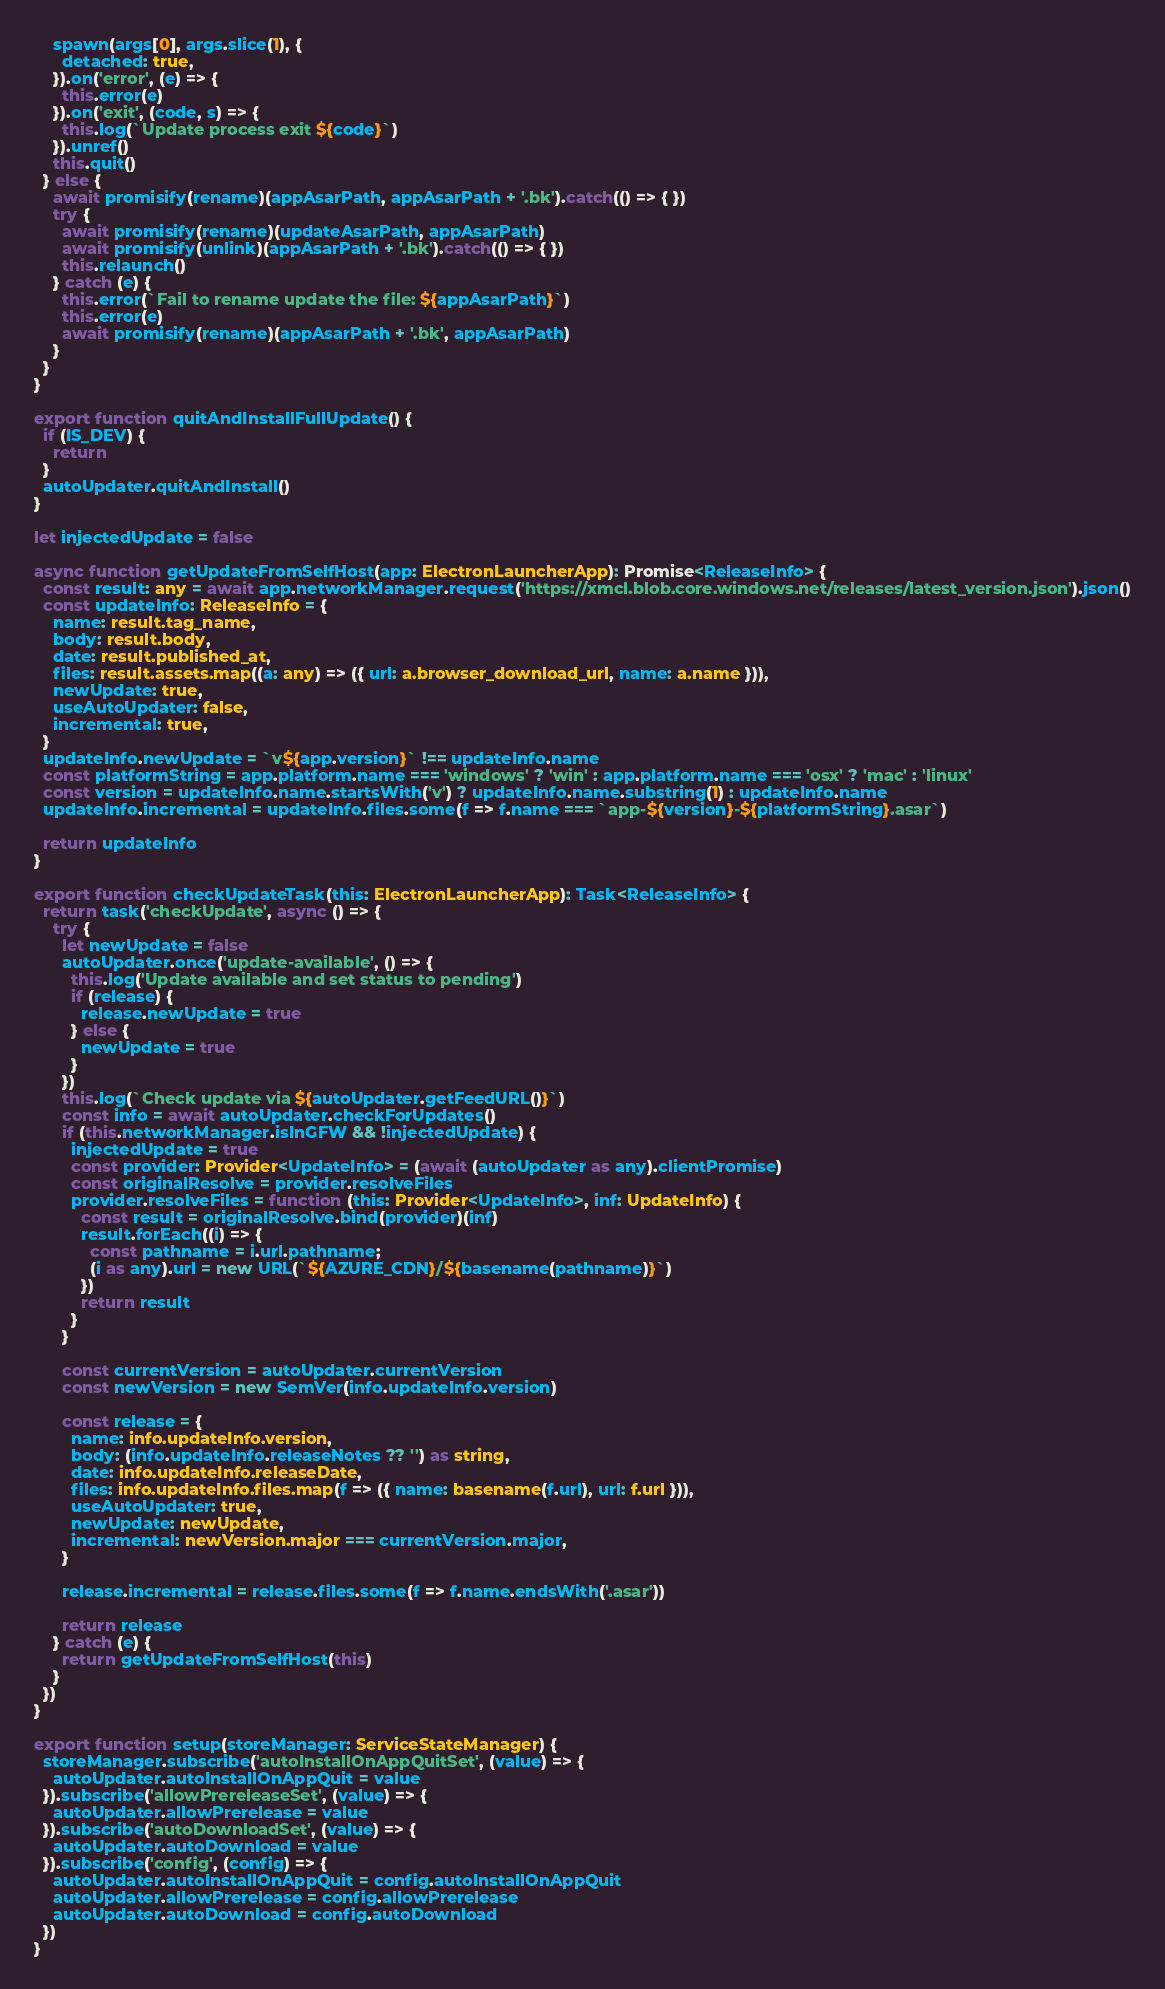<code> <loc_0><loc_0><loc_500><loc_500><_TypeScript_>
    spawn(args[0], args.slice(1), {
      detached: true,
    }).on('error', (e) => {
      this.error(e)
    }).on('exit', (code, s) => {
      this.log(`Update process exit ${code}`)
    }).unref()
    this.quit()
  } else {
    await promisify(rename)(appAsarPath, appAsarPath + '.bk').catch(() => { })
    try {
      await promisify(rename)(updateAsarPath, appAsarPath)
      await promisify(unlink)(appAsarPath + '.bk').catch(() => { })
      this.relaunch()
    } catch (e) {
      this.error(`Fail to rename update the file: ${appAsarPath}`)
      this.error(e)
      await promisify(rename)(appAsarPath + '.bk', appAsarPath)
    }
  }
}

export function quitAndInstallFullUpdate() {
  if (IS_DEV) {
    return
  }
  autoUpdater.quitAndInstall()
}

let injectedUpdate = false

async function getUpdateFromSelfHost(app: ElectronLauncherApp): Promise<ReleaseInfo> {
  const result: any = await app.networkManager.request('https://xmcl.blob.core.windows.net/releases/latest_version.json').json()
  const updateInfo: ReleaseInfo = {
    name: result.tag_name,
    body: result.body,
    date: result.published_at,
    files: result.assets.map((a: any) => ({ url: a.browser_download_url, name: a.name })),
    newUpdate: true,
    useAutoUpdater: false,
    incremental: true,
  }
  updateInfo.newUpdate = `v${app.version}` !== updateInfo.name
  const platformString = app.platform.name === 'windows' ? 'win' : app.platform.name === 'osx' ? 'mac' : 'linux'
  const version = updateInfo.name.startsWith('v') ? updateInfo.name.substring(1) : updateInfo.name
  updateInfo.incremental = updateInfo.files.some(f => f.name === `app-${version}-${platformString}.asar`)

  return updateInfo
}

export function checkUpdateTask(this: ElectronLauncherApp): Task<ReleaseInfo> {
  return task('checkUpdate', async () => {
    try {
      let newUpdate = false
      autoUpdater.once('update-available', () => {
        this.log('Update available and set status to pending')
        if (release) {
          release.newUpdate = true
        } else {
          newUpdate = true
        }
      })
      this.log(`Check update via ${autoUpdater.getFeedURL()}`)
      const info = await autoUpdater.checkForUpdates()
      if (this.networkManager.isInGFW && !injectedUpdate) {
        injectedUpdate = true
        const provider: Provider<UpdateInfo> = (await (autoUpdater as any).clientPromise)
        const originalResolve = provider.resolveFiles
        provider.resolveFiles = function (this: Provider<UpdateInfo>, inf: UpdateInfo) {
          const result = originalResolve.bind(provider)(inf)
          result.forEach((i) => {
            const pathname = i.url.pathname;
            (i as any).url = new URL(`${AZURE_CDN}/${basename(pathname)}`)
          })
          return result
        }
      }

      const currentVersion = autoUpdater.currentVersion
      const newVersion = new SemVer(info.updateInfo.version)

      const release = {
        name: info.updateInfo.version,
        body: (info.updateInfo.releaseNotes ?? '') as string,
        date: info.updateInfo.releaseDate,
        files: info.updateInfo.files.map(f => ({ name: basename(f.url), url: f.url })),
        useAutoUpdater: true,
        newUpdate: newUpdate,
        incremental: newVersion.major === currentVersion.major,
      }

      release.incremental = release.files.some(f => f.name.endsWith('.asar'))

      return release
    } catch (e) {
      return getUpdateFromSelfHost(this)
    }
  })
}

export function setup(storeManager: ServiceStateManager) {
  storeManager.subscribe('autoInstallOnAppQuitSet', (value) => {
    autoUpdater.autoInstallOnAppQuit = value
  }).subscribe('allowPrereleaseSet', (value) => {
    autoUpdater.allowPrerelease = value
  }).subscribe('autoDownloadSet', (value) => {
    autoUpdater.autoDownload = value
  }).subscribe('config', (config) => {
    autoUpdater.autoInstallOnAppQuit = config.autoInstallOnAppQuit
    autoUpdater.allowPrerelease = config.allowPrerelease
    autoUpdater.autoDownload = config.autoDownload
  })
}
</code> 